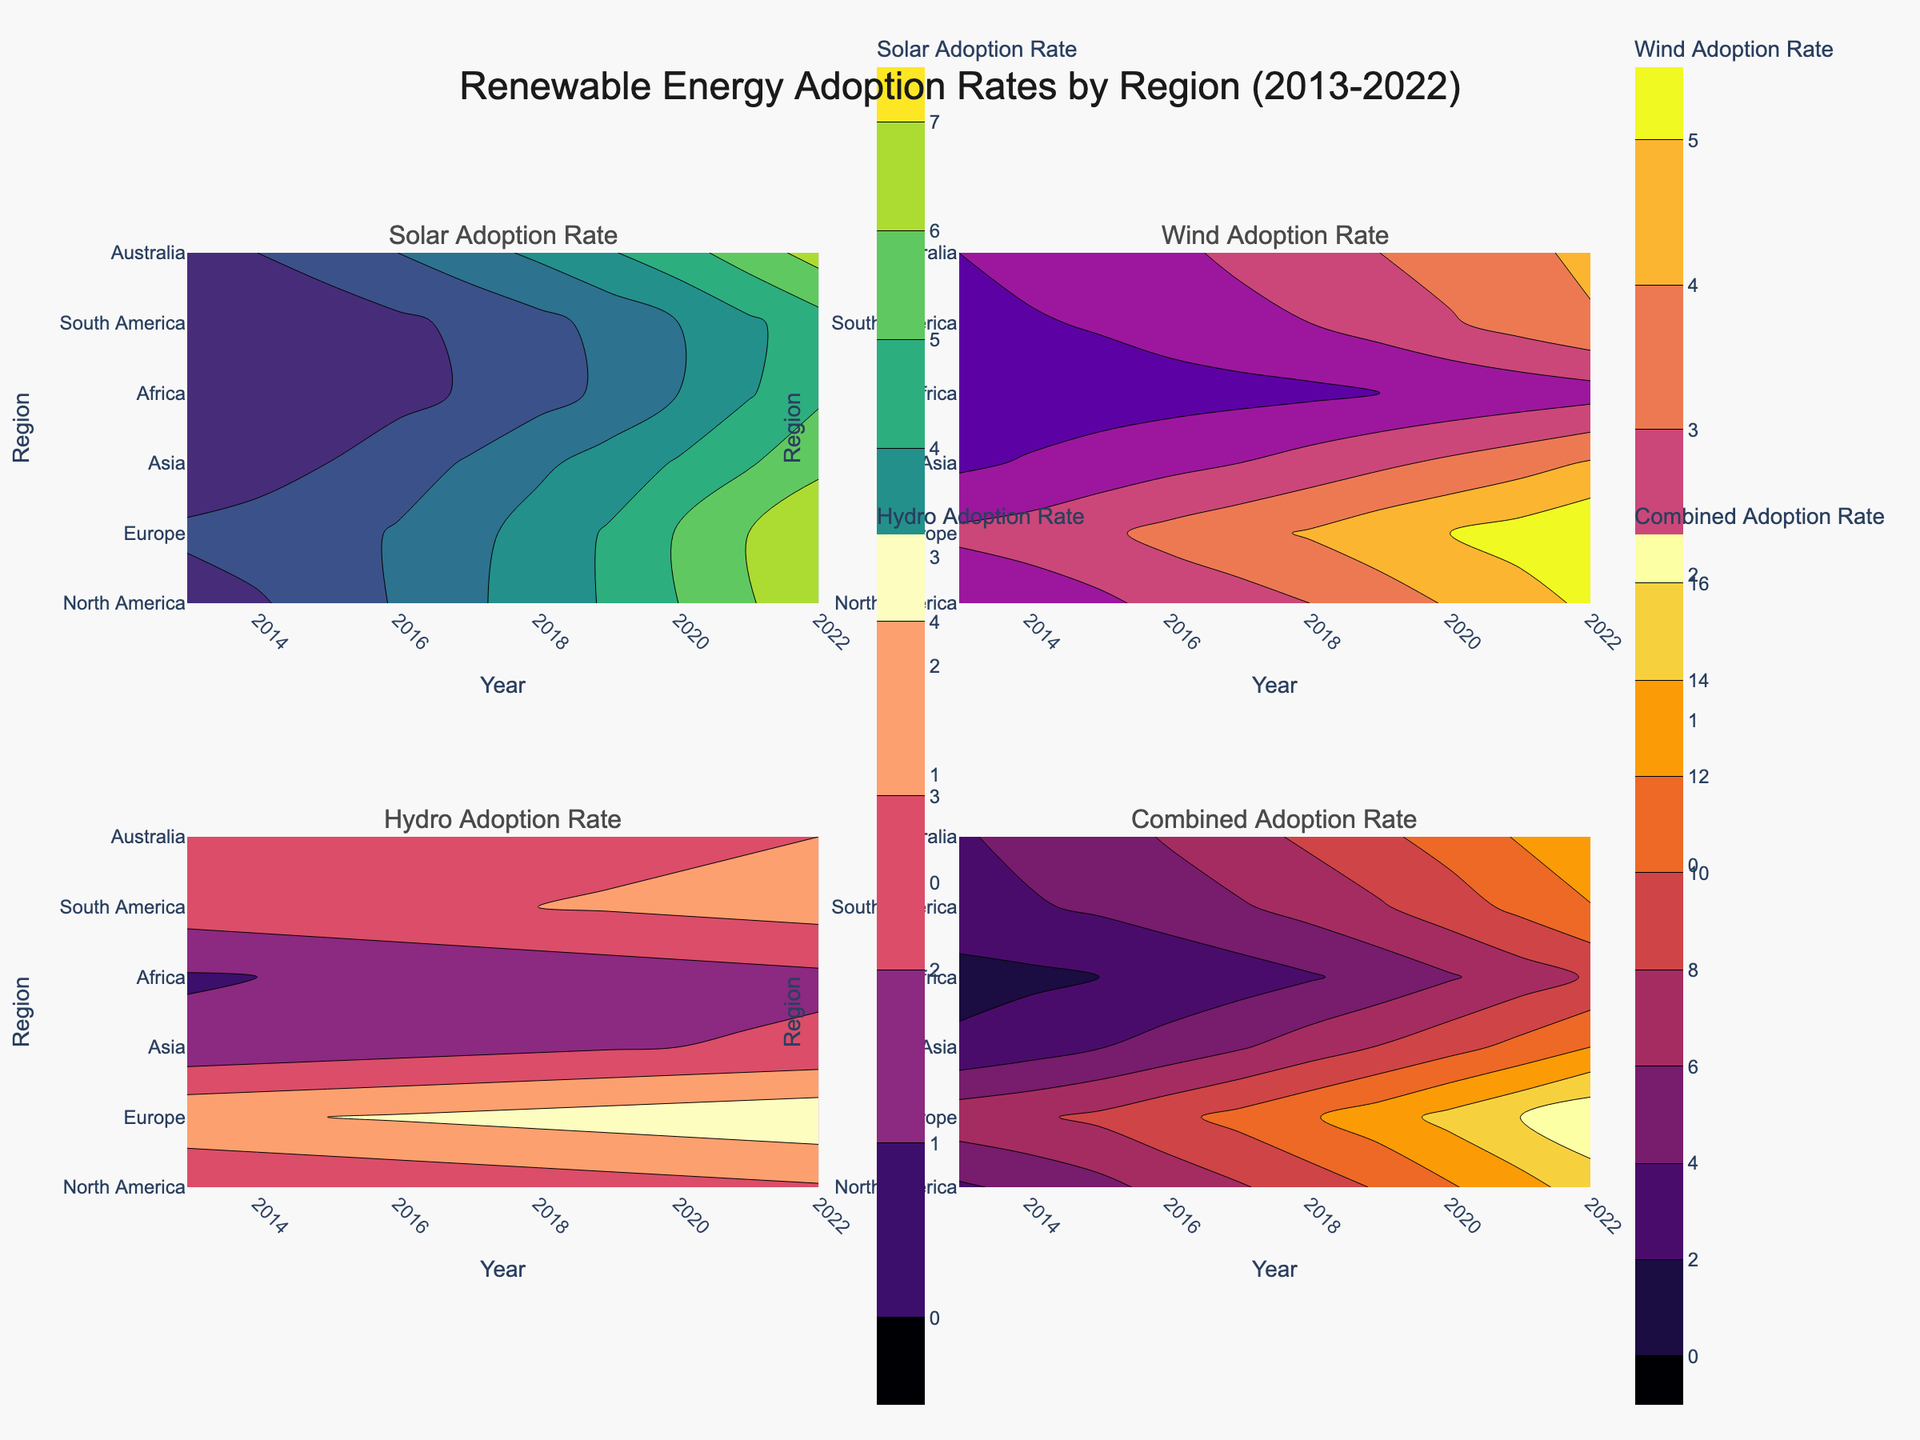What is the title of the figure? The title of the figure is prominently displayed at the top. It reads "Renewable Energy Adoption Rates by Region (2013-2022)."
Answer: Renewable Energy Adoption Rates by Region (2013-2022) Which region shows the highest solar adoption rate in 2022? To find this, look at the contour plot for Solar Adoption Rate. In 2022, locate the region with the highest contour value.
Answer: Europe How does the wind adoption rate in North America in 2016 compare to that of 2018? Look at the contour plot for Wind Adoption Rate and identify the values for North America in 2016 and 2018. Then, compare these values.
Answer: It increased from 2.3 to 3.0 What is the combined adoption rate for Asia in 2020? Use the Combined Adoption Rate contour plot, find Asia for the year 2020, and read the value from the contour lines.
Answer: 9.3 Which energy source has shown the most consistent growth in Europe over the decade? Analyze the contour plots for Solar, Wind, and Hydro Adoption Rates, observe the smoothness of contour lines for Europe from 2013 to 2022, and identify which energy type shows steady, consistent increments.
Answer: Solar How has Africa's hydro adoption rate changed from 2013 to 2022? Observe the contour plot for Hydro Adoption Rate, and follow the contour line changes for Africa between 2013 and 2022 to assess the trend.
Answer: It increased from 0.9 to 1.8 Which region shows the lowest wind adoption rate in 2022? Look at the contour plot for Wind Adoption Rate for the year 2022, identify the region with the lowest contour value.
Answer: Africa Which region had the highest combined adoption rate in 2018? Using the Combined Adoption Rate contour plot, find the year 2018, and identify which region had the highest contour value.
Answer: Europe What trend is observed in Australia's solar adoption rate from 2013 to 2022? Look at the contour plot for Solar Adoption Rate and observe the changes in contour values for Australia from 2013 to 2022. Summarize how these values change over time.
Answer: It consistently increased Between 2015 and 2020, which region experienced the most significant increase in solar adoption rate? Examine the contour plot for Solar Adoption Rate and measure the changes in contour values for each region between 2015 and 2020. Identify the region with the largest increase.
Answer: North America 